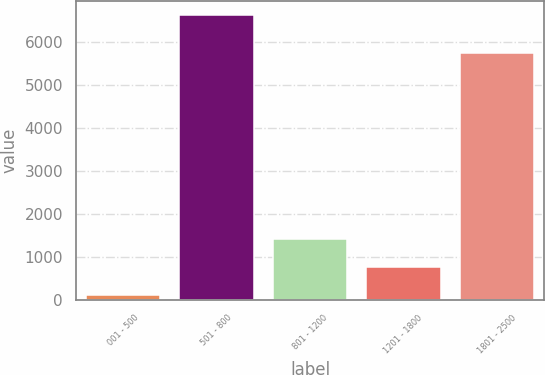Convert chart. <chart><loc_0><loc_0><loc_500><loc_500><bar_chart><fcel>001 - 500<fcel>501 - 800<fcel>801 - 1200<fcel>1201 - 1800<fcel>1801 - 2500<nl><fcel>111<fcel>6614<fcel>1411.6<fcel>761.3<fcel>5739<nl></chart> 